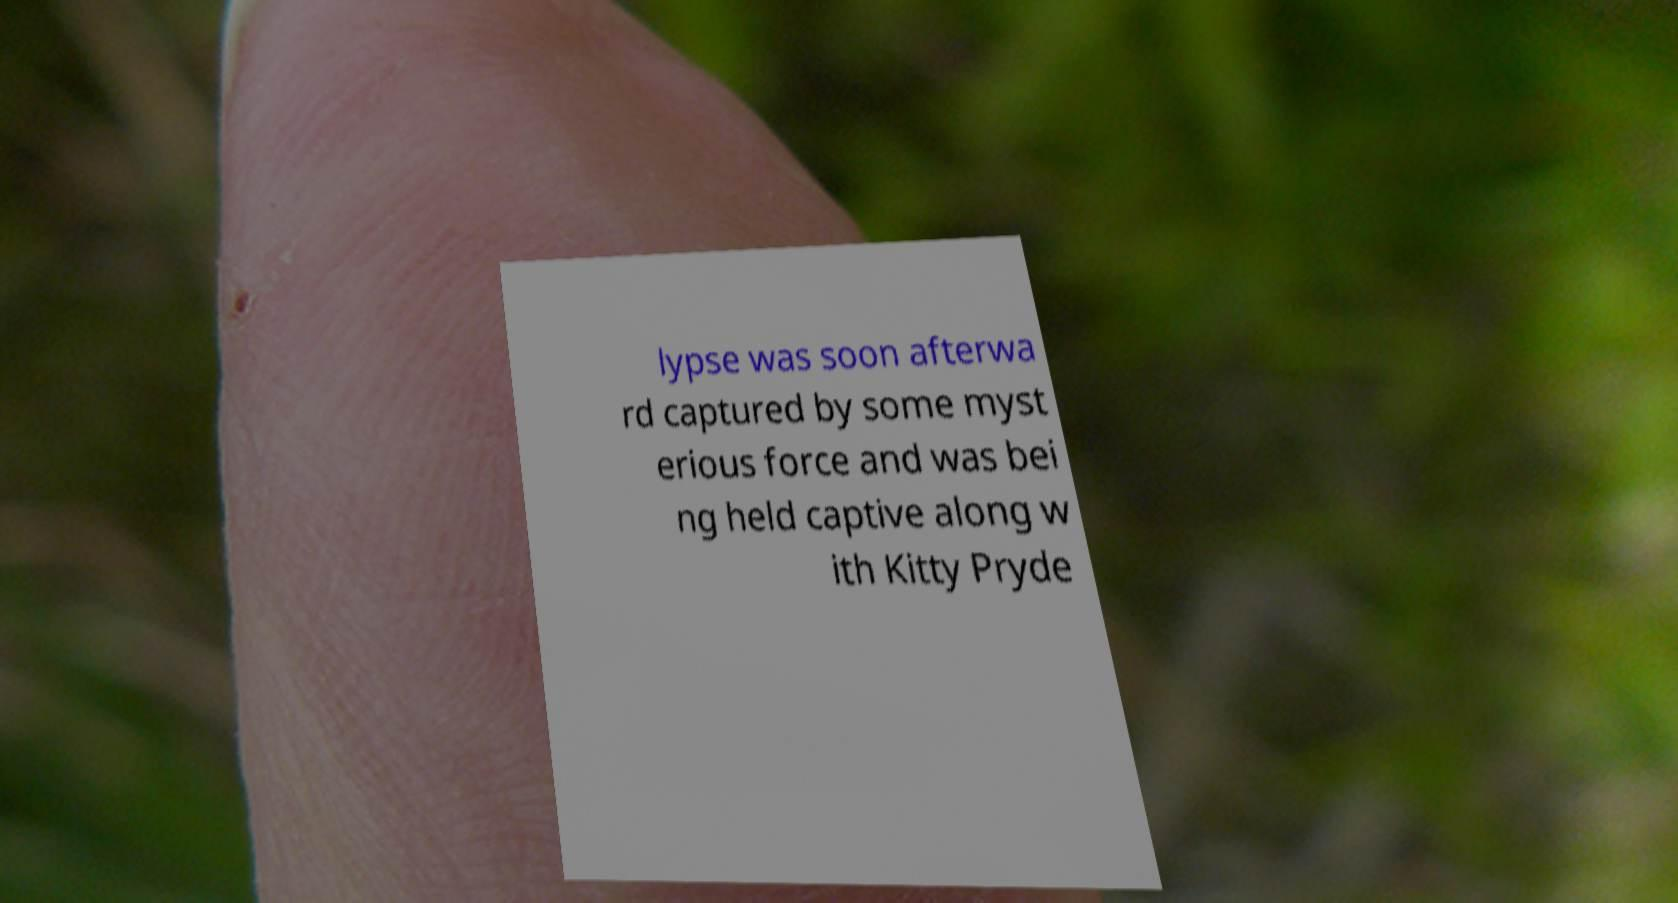Can you read and provide the text displayed in the image?This photo seems to have some interesting text. Can you extract and type it out for me? lypse was soon afterwa rd captured by some myst erious force and was bei ng held captive along w ith Kitty Pryde 